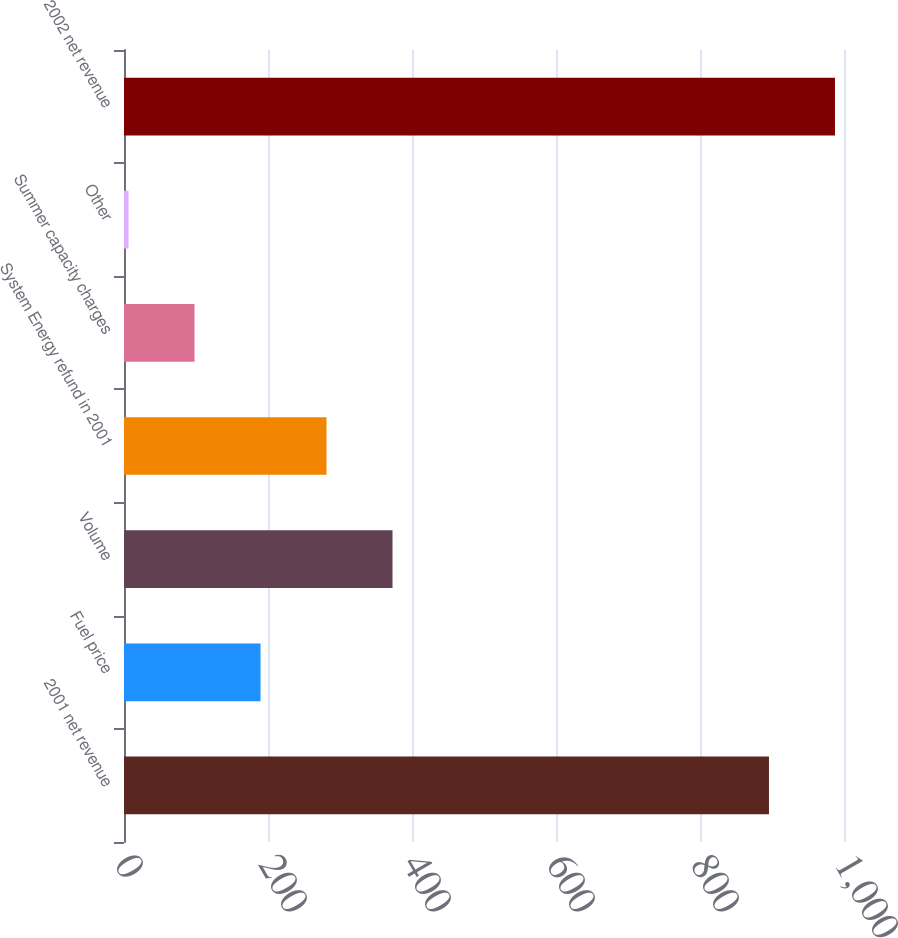Convert chart. <chart><loc_0><loc_0><loc_500><loc_500><bar_chart><fcel>2001 net revenue<fcel>Fuel price<fcel>Volume<fcel>System Energy refund in 2001<fcel>Summer capacity charges<fcel>Other<fcel>2002 net revenue<nl><fcel>895.8<fcel>189.62<fcel>372.94<fcel>281.28<fcel>97.96<fcel>6.3<fcel>987.46<nl></chart> 